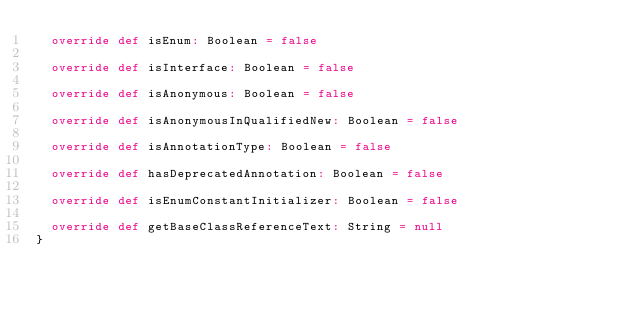<code> <loc_0><loc_0><loc_500><loc_500><_Scala_>  override def isEnum: Boolean = false

  override def isInterface: Boolean = false

  override def isAnonymous: Boolean = false

  override def isAnonymousInQualifiedNew: Boolean = false

  override def isAnnotationType: Boolean = false

  override def hasDeprecatedAnnotation: Boolean = false

  override def isEnumConstantInitializer: Boolean = false

  override def getBaseClassReferenceText: String = null
}</code> 